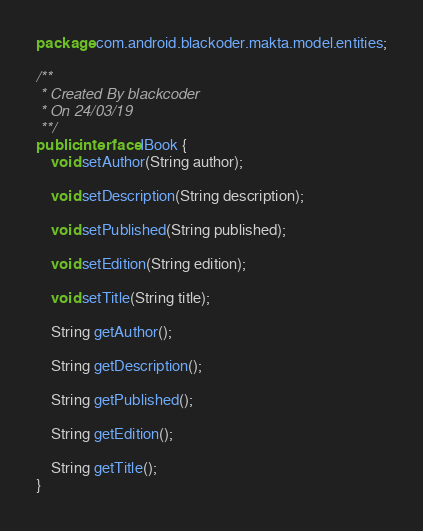<code> <loc_0><loc_0><loc_500><loc_500><_Java_>package com.android.blackoder.makta.model.entities;

/**
 * Created By blackcoder
 * On 24/03/19
 **/
public interface IBook {
    void setAuthor(String author);

    void setDescription(String description);

    void setPublished(String published);

    void setEdition(String edition);

    void setTitle(String title);

    String getAuthor();

    String getDescription();

    String getPublished();

    String getEdition();

    String getTitle();
}
</code> 